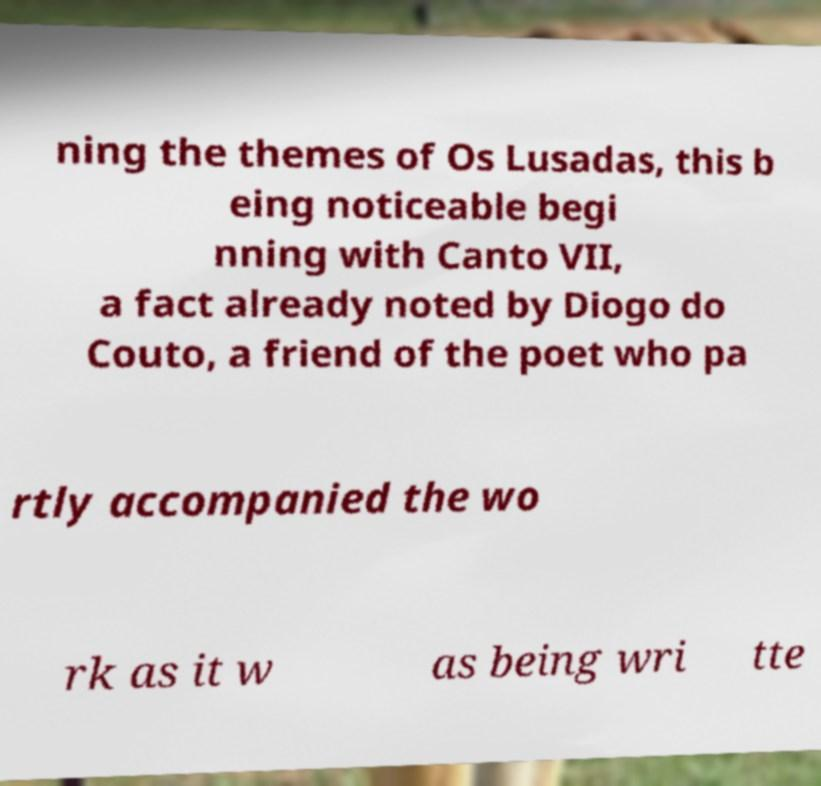Can you read and provide the text displayed in the image?This photo seems to have some interesting text. Can you extract and type it out for me? ning the themes of Os Lusadas, this b eing noticeable begi nning with Canto VII, a fact already noted by Diogo do Couto, a friend of the poet who pa rtly accompanied the wo rk as it w as being wri tte 